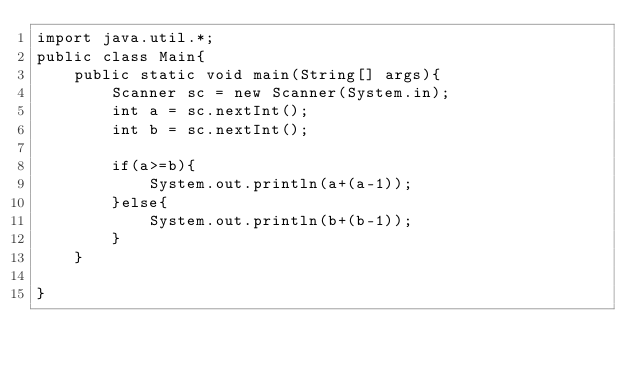Convert code to text. <code><loc_0><loc_0><loc_500><loc_500><_Java_>import java.util.*;
public class Main{
    public static void main(String[] args){
        Scanner sc = new Scanner(System.in);
        int a = sc.nextInt();
        int b = sc.nextInt();

        if(a>=b){
            System.out.println(a+(a-1));
        }else{
            System.out.println(b+(b-1));
        }
    }

}
</code> 